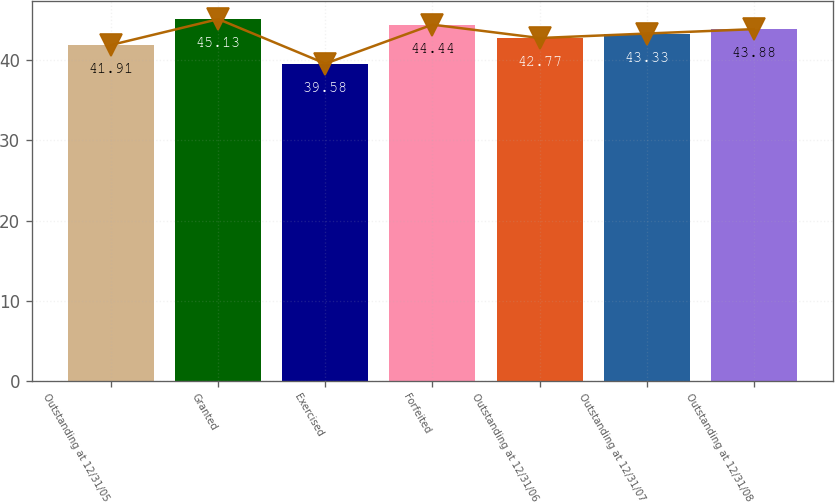Convert chart to OTSL. <chart><loc_0><loc_0><loc_500><loc_500><bar_chart><fcel>Outstanding at 12/31/05<fcel>Granted<fcel>Exercised<fcel>Forfeited<fcel>Outstanding at 12/31/06<fcel>Outstanding at 12/31/07<fcel>Outstanding at 12/31/08<nl><fcel>41.91<fcel>45.13<fcel>39.58<fcel>44.44<fcel>42.77<fcel>43.33<fcel>43.88<nl></chart> 